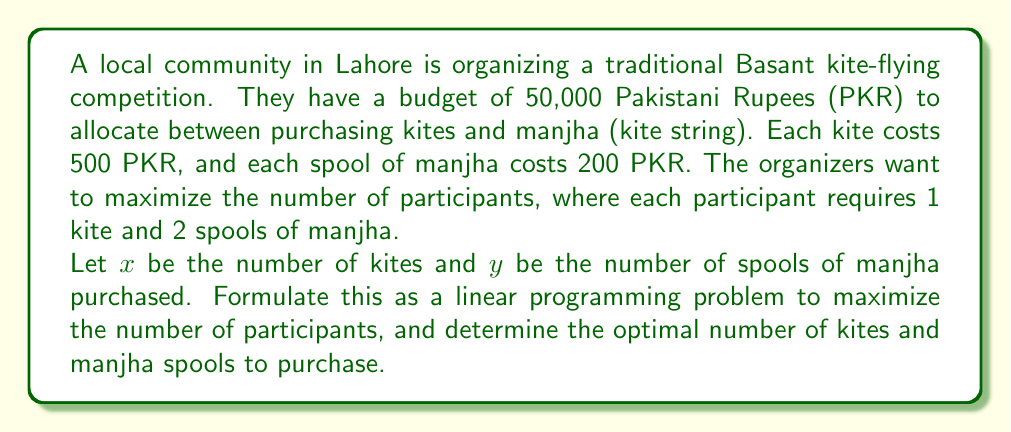Solve this math problem. To solve this problem, we'll follow these steps:

1) Define the objective function:
   We want to maximize the number of participants. Each participant needs 1 kite and 2 spools of manjha. So, the number of participants is limited by the minimum of $x$ and $y/2$. Our objective is to maximize $\min(x, y/2)$.

2) Define the constraints:
   a) Budget constraint: $500x + 200y \leq 50000$
   b) Non-negativity: $x \geq 0, y \geq 0$
   c) Integer constraint: $x$ and $y$ must be integers

3) To solve this, we can introduce a new variable $z$ representing the number of participants:
   $z \leq x$
   $z \leq y/2$

4) Our linear programming problem becomes:
   Maximize $z$
   Subject to:
   $z \leq x$
   $z \leq y/2$
   $500x + 200y \leq 50000$
   $x, y, z \geq 0$
   $x, y, z$ are integers

5) We can solve this graphically or using the simplex method. The optimal solution will occur where:
   $z = x = y/2$
   $500x + 200y = 50000$

6) Substituting $y = 2x$ into the budget constraint:
   $500x + 200(2x) = 50000$
   $500x + 400x = 50000$
   $900x = 50000$
   $x = 50000/900 = 55.56$

7) Rounding down to satisfy the integer constraint:
   $x = 55$ kites
   $y = 2x = 110$ spools of manjha

8) Verify the budget:
   $500(55) + 200(110) = 27500 + 22000 = 49500 \leq 50000$

Therefore, the optimal solution is to purchase 55 kites and 110 spools of manjha, allowing for 55 participants.
Answer: The optimal allocation is to purchase 55 kites and 110 spools of manjha, maximizing the number of participants at 55. 